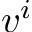Convert formula to latex. <formula><loc_0><loc_0><loc_500><loc_500>v ^ { i }</formula> 